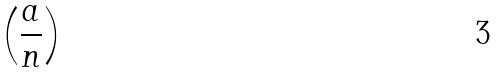<formula> <loc_0><loc_0><loc_500><loc_500>\left ( { \frac { a } { n } } \right )</formula> 